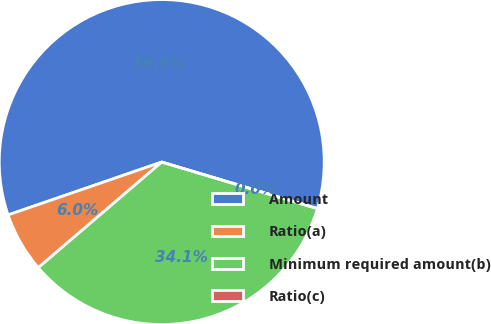Convert chart to OTSL. <chart><loc_0><loc_0><loc_500><loc_500><pie_chart><fcel>Amount<fcel>Ratio(a)<fcel>Minimum required amount(b)<fcel>Ratio(c)<nl><fcel>59.9%<fcel>5.99%<fcel>34.11%<fcel>0.0%<nl></chart> 